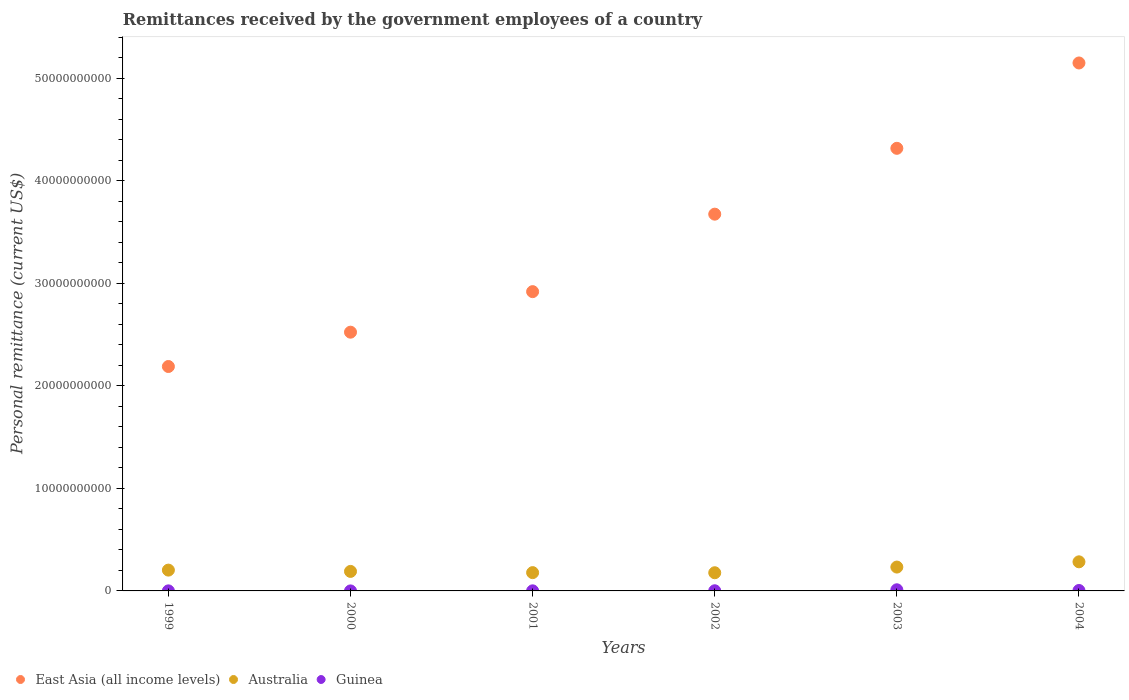What is the remittances received by the government employees in Guinea in 2002?
Offer a very short reply. 1.52e+07. Across all years, what is the maximum remittances received by the government employees in Australia?
Your answer should be compact. 2.84e+09. Across all years, what is the minimum remittances received by the government employees in East Asia (all income levels)?
Keep it short and to the point. 2.19e+1. In which year was the remittances received by the government employees in Australia minimum?
Make the answer very short. 2002. What is the total remittances received by the government employees in East Asia (all income levels) in the graph?
Offer a very short reply. 2.08e+11. What is the difference between the remittances received by the government employees in East Asia (all income levels) in 2000 and that in 2003?
Offer a terse response. -1.79e+1. What is the difference between the remittances received by the government employees in Australia in 2004 and the remittances received by the government employees in Guinea in 2003?
Make the answer very short. 2.73e+09. What is the average remittances received by the government employees in Guinea per year?
Ensure brevity in your answer.  3.06e+07. In the year 1999, what is the difference between the remittances received by the government employees in Australia and remittances received by the government employees in East Asia (all income levels)?
Your response must be concise. -1.99e+1. In how many years, is the remittances received by the government employees in Guinea greater than 34000000000 US$?
Keep it short and to the point. 0. What is the ratio of the remittances received by the government employees in East Asia (all income levels) in 2000 to that in 2002?
Offer a terse response. 0.69. Is the remittances received by the government employees in East Asia (all income levels) in 1999 less than that in 2002?
Your response must be concise. Yes. Is the difference between the remittances received by the government employees in Australia in 2001 and 2002 greater than the difference between the remittances received by the government employees in East Asia (all income levels) in 2001 and 2002?
Ensure brevity in your answer.  Yes. What is the difference between the highest and the second highest remittances received by the government employees in Guinea?
Your response must be concise. 6.94e+07. What is the difference between the highest and the lowest remittances received by the government employees in Guinea?
Your answer should be compact. 1.10e+08. In how many years, is the remittances received by the government employees in Guinea greater than the average remittances received by the government employees in Guinea taken over all years?
Ensure brevity in your answer.  2. Is it the case that in every year, the sum of the remittances received by the government employees in Australia and remittances received by the government employees in East Asia (all income levels)  is greater than the remittances received by the government employees in Guinea?
Ensure brevity in your answer.  Yes. Is the remittances received by the government employees in Australia strictly greater than the remittances received by the government employees in East Asia (all income levels) over the years?
Your answer should be compact. No. What is the difference between two consecutive major ticks on the Y-axis?
Give a very brief answer. 1.00e+1. Are the values on the major ticks of Y-axis written in scientific E-notation?
Your answer should be very brief. No. Does the graph contain grids?
Your answer should be very brief. No. Where does the legend appear in the graph?
Your answer should be compact. Bottom left. How many legend labels are there?
Offer a very short reply. 3. What is the title of the graph?
Offer a very short reply. Remittances received by the government employees of a country. What is the label or title of the X-axis?
Offer a terse response. Years. What is the label or title of the Y-axis?
Keep it short and to the point. Personal remittance (current US$). What is the Personal remittance (current US$) in East Asia (all income levels) in 1999?
Offer a terse response. 2.19e+1. What is the Personal remittance (current US$) in Australia in 1999?
Ensure brevity in your answer.  2.03e+09. What is the Personal remittance (current US$) of Guinea in 1999?
Give a very brief answer. 6.02e+06. What is the Personal remittance (current US$) of East Asia (all income levels) in 2000?
Your response must be concise. 2.52e+1. What is the Personal remittance (current US$) of Australia in 2000?
Keep it short and to the point. 1.90e+09. What is the Personal remittance (current US$) of Guinea in 2000?
Offer a terse response. 1.17e+06. What is the Personal remittance (current US$) of East Asia (all income levels) in 2001?
Provide a short and direct response. 2.92e+1. What is the Personal remittance (current US$) in Australia in 2001?
Provide a short and direct response. 1.78e+09. What is the Personal remittance (current US$) in Guinea in 2001?
Ensure brevity in your answer.  8.72e+06. What is the Personal remittance (current US$) of East Asia (all income levels) in 2002?
Keep it short and to the point. 3.67e+1. What is the Personal remittance (current US$) of Australia in 2002?
Give a very brief answer. 1.77e+09. What is the Personal remittance (current US$) of Guinea in 2002?
Provide a succinct answer. 1.52e+07. What is the Personal remittance (current US$) in East Asia (all income levels) in 2003?
Your answer should be compact. 4.32e+1. What is the Personal remittance (current US$) in Australia in 2003?
Make the answer very short. 2.33e+09. What is the Personal remittance (current US$) in Guinea in 2003?
Ensure brevity in your answer.  1.11e+08. What is the Personal remittance (current US$) of East Asia (all income levels) in 2004?
Ensure brevity in your answer.  5.15e+1. What is the Personal remittance (current US$) of Australia in 2004?
Keep it short and to the point. 2.84e+09. What is the Personal remittance (current US$) of Guinea in 2004?
Ensure brevity in your answer.  4.16e+07. Across all years, what is the maximum Personal remittance (current US$) in East Asia (all income levels)?
Ensure brevity in your answer.  5.15e+1. Across all years, what is the maximum Personal remittance (current US$) of Australia?
Provide a succinct answer. 2.84e+09. Across all years, what is the maximum Personal remittance (current US$) of Guinea?
Provide a succinct answer. 1.11e+08. Across all years, what is the minimum Personal remittance (current US$) in East Asia (all income levels)?
Provide a short and direct response. 2.19e+1. Across all years, what is the minimum Personal remittance (current US$) of Australia?
Your answer should be very brief. 1.77e+09. Across all years, what is the minimum Personal remittance (current US$) in Guinea?
Your response must be concise. 1.17e+06. What is the total Personal remittance (current US$) in East Asia (all income levels) in the graph?
Give a very brief answer. 2.08e+11. What is the total Personal remittance (current US$) in Australia in the graph?
Your response must be concise. 1.27e+1. What is the total Personal remittance (current US$) of Guinea in the graph?
Give a very brief answer. 1.84e+08. What is the difference between the Personal remittance (current US$) in East Asia (all income levels) in 1999 and that in 2000?
Provide a short and direct response. -3.35e+09. What is the difference between the Personal remittance (current US$) in Australia in 1999 and that in 2000?
Your answer should be compact. 1.26e+08. What is the difference between the Personal remittance (current US$) of Guinea in 1999 and that in 2000?
Give a very brief answer. 4.85e+06. What is the difference between the Personal remittance (current US$) in East Asia (all income levels) in 1999 and that in 2001?
Make the answer very short. -7.30e+09. What is the difference between the Personal remittance (current US$) of Australia in 1999 and that in 2001?
Provide a succinct answer. 2.46e+08. What is the difference between the Personal remittance (current US$) of Guinea in 1999 and that in 2001?
Provide a succinct answer. -2.70e+06. What is the difference between the Personal remittance (current US$) in East Asia (all income levels) in 1999 and that in 2002?
Your answer should be very brief. -1.49e+1. What is the difference between the Personal remittance (current US$) of Australia in 1999 and that in 2002?
Keep it short and to the point. 2.57e+08. What is the difference between the Personal remittance (current US$) in Guinea in 1999 and that in 2002?
Offer a terse response. -9.17e+06. What is the difference between the Personal remittance (current US$) of East Asia (all income levels) in 1999 and that in 2003?
Provide a short and direct response. -2.13e+1. What is the difference between the Personal remittance (current US$) in Australia in 1999 and that in 2003?
Give a very brief answer. -2.97e+08. What is the difference between the Personal remittance (current US$) of Guinea in 1999 and that in 2003?
Your response must be concise. -1.05e+08. What is the difference between the Personal remittance (current US$) in East Asia (all income levels) in 1999 and that in 2004?
Provide a short and direct response. -2.96e+1. What is the difference between the Personal remittance (current US$) of Australia in 1999 and that in 2004?
Provide a short and direct response. -8.08e+08. What is the difference between the Personal remittance (current US$) in Guinea in 1999 and that in 2004?
Ensure brevity in your answer.  -3.56e+07. What is the difference between the Personal remittance (current US$) of East Asia (all income levels) in 2000 and that in 2001?
Keep it short and to the point. -3.95e+09. What is the difference between the Personal remittance (current US$) of Australia in 2000 and that in 2001?
Offer a terse response. 1.20e+08. What is the difference between the Personal remittance (current US$) in Guinea in 2000 and that in 2001?
Ensure brevity in your answer.  -7.55e+06. What is the difference between the Personal remittance (current US$) in East Asia (all income levels) in 2000 and that in 2002?
Your response must be concise. -1.15e+1. What is the difference between the Personal remittance (current US$) in Australia in 2000 and that in 2002?
Your response must be concise. 1.31e+08. What is the difference between the Personal remittance (current US$) in Guinea in 2000 and that in 2002?
Give a very brief answer. -1.40e+07. What is the difference between the Personal remittance (current US$) of East Asia (all income levels) in 2000 and that in 2003?
Provide a short and direct response. -1.79e+1. What is the difference between the Personal remittance (current US$) of Australia in 2000 and that in 2003?
Provide a succinct answer. -4.23e+08. What is the difference between the Personal remittance (current US$) of Guinea in 2000 and that in 2003?
Give a very brief answer. -1.10e+08. What is the difference between the Personal remittance (current US$) of East Asia (all income levels) in 2000 and that in 2004?
Give a very brief answer. -2.63e+1. What is the difference between the Personal remittance (current US$) in Australia in 2000 and that in 2004?
Make the answer very short. -9.34e+08. What is the difference between the Personal remittance (current US$) in Guinea in 2000 and that in 2004?
Ensure brevity in your answer.  -4.05e+07. What is the difference between the Personal remittance (current US$) in East Asia (all income levels) in 2001 and that in 2002?
Keep it short and to the point. -7.56e+09. What is the difference between the Personal remittance (current US$) of Australia in 2001 and that in 2002?
Provide a short and direct response. 1.09e+07. What is the difference between the Personal remittance (current US$) in Guinea in 2001 and that in 2002?
Make the answer very short. -6.47e+06. What is the difference between the Personal remittance (current US$) in East Asia (all income levels) in 2001 and that in 2003?
Your answer should be compact. -1.40e+1. What is the difference between the Personal remittance (current US$) in Australia in 2001 and that in 2003?
Make the answer very short. -5.43e+08. What is the difference between the Personal remittance (current US$) of Guinea in 2001 and that in 2003?
Provide a short and direct response. -1.02e+08. What is the difference between the Personal remittance (current US$) in East Asia (all income levels) in 2001 and that in 2004?
Provide a short and direct response. -2.23e+1. What is the difference between the Personal remittance (current US$) in Australia in 2001 and that in 2004?
Your answer should be very brief. -1.05e+09. What is the difference between the Personal remittance (current US$) in Guinea in 2001 and that in 2004?
Give a very brief answer. -3.29e+07. What is the difference between the Personal remittance (current US$) of East Asia (all income levels) in 2002 and that in 2003?
Your answer should be very brief. -6.42e+09. What is the difference between the Personal remittance (current US$) in Australia in 2002 and that in 2003?
Offer a terse response. -5.54e+08. What is the difference between the Personal remittance (current US$) in Guinea in 2002 and that in 2003?
Your response must be concise. -9.59e+07. What is the difference between the Personal remittance (current US$) in East Asia (all income levels) in 2002 and that in 2004?
Keep it short and to the point. -1.47e+1. What is the difference between the Personal remittance (current US$) in Australia in 2002 and that in 2004?
Offer a very short reply. -1.06e+09. What is the difference between the Personal remittance (current US$) of Guinea in 2002 and that in 2004?
Give a very brief answer. -2.64e+07. What is the difference between the Personal remittance (current US$) of East Asia (all income levels) in 2003 and that in 2004?
Offer a terse response. -8.32e+09. What is the difference between the Personal remittance (current US$) of Australia in 2003 and that in 2004?
Your answer should be compact. -5.11e+08. What is the difference between the Personal remittance (current US$) in Guinea in 2003 and that in 2004?
Give a very brief answer. 6.94e+07. What is the difference between the Personal remittance (current US$) of East Asia (all income levels) in 1999 and the Personal remittance (current US$) of Australia in 2000?
Offer a very short reply. 2.00e+1. What is the difference between the Personal remittance (current US$) of East Asia (all income levels) in 1999 and the Personal remittance (current US$) of Guinea in 2000?
Your answer should be compact. 2.19e+1. What is the difference between the Personal remittance (current US$) of Australia in 1999 and the Personal remittance (current US$) of Guinea in 2000?
Your answer should be very brief. 2.03e+09. What is the difference between the Personal remittance (current US$) of East Asia (all income levels) in 1999 and the Personal remittance (current US$) of Australia in 2001?
Provide a short and direct response. 2.01e+1. What is the difference between the Personal remittance (current US$) of East Asia (all income levels) in 1999 and the Personal remittance (current US$) of Guinea in 2001?
Provide a short and direct response. 2.19e+1. What is the difference between the Personal remittance (current US$) of Australia in 1999 and the Personal remittance (current US$) of Guinea in 2001?
Offer a very short reply. 2.02e+09. What is the difference between the Personal remittance (current US$) of East Asia (all income levels) in 1999 and the Personal remittance (current US$) of Australia in 2002?
Make the answer very short. 2.01e+1. What is the difference between the Personal remittance (current US$) in East Asia (all income levels) in 1999 and the Personal remittance (current US$) in Guinea in 2002?
Give a very brief answer. 2.19e+1. What is the difference between the Personal remittance (current US$) of Australia in 1999 and the Personal remittance (current US$) of Guinea in 2002?
Provide a short and direct response. 2.01e+09. What is the difference between the Personal remittance (current US$) in East Asia (all income levels) in 1999 and the Personal remittance (current US$) in Australia in 2003?
Provide a succinct answer. 1.96e+1. What is the difference between the Personal remittance (current US$) in East Asia (all income levels) in 1999 and the Personal remittance (current US$) in Guinea in 2003?
Your answer should be very brief. 2.18e+1. What is the difference between the Personal remittance (current US$) of Australia in 1999 and the Personal remittance (current US$) of Guinea in 2003?
Offer a terse response. 1.92e+09. What is the difference between the Personal remittance (current US$) of East Asia (all income levels) in 1999 and the Personal remittance (current US$) of Australia in 2004?
Your answer should be compact. 1.90e+1. What is the difference between the Personal remittance (current US$) of East Asia (all income levels) in 1999 and the Personal remittance (current US$) of Guinea in 2004?
Your answer should be very brief. 2.18e+1. What is the difference between the Personal remittance (current US$) in Australia in 1999 and the Personal remittance (current US$) in Guinea in 2004?
Offer a terse response. 1.99e+09. What is the difference between the Personal remittance (current US$) of East Asia (all income levels) in 2000 and the Personal remittance (current US$) of Australia in 2001?
Ensure brevity in your answer.  2.34e+1. What is the difference between the Personal remittance (current US$) in East Asia (all income levels) in 2000 and the Personal remittance (current US$) in Guinea in 2001?
Keep it short and to the point. 2.52e+1. What is the difference between the Personal remittance (current US$) in Australia in 2000 and the Personal remittance (current US$) in Guinea in 2001?
Give a very brief answer. 1.89e+09. What is the difference between the Personal remittance (current US$) in East Asia (all income levels) in 2000 and the Personal remittance (current US$) in Australia in 2002?
Offer a very short reply. 2.35e+1. What is the difference between the Personal remittance (current US$) of East Asia (all income levels) in 2000 and the Personal remittance (current US$) of Guinea in 2002?
Offer a very short reply. 2.52e+1. What is the difference between the Personal remittance (current US$) of Australia in 2000 and the Personal remittance (current US$) of Guinea in 2002?
Provide a short and direct response. 1.89e+09. What is the difference between the Personal remittance (current US$) of East Asia (all income levels) in 2000 and the Personal remittance (current US$) of Australia in 2003?
Your answer should be compact. 2.29e+1. What is the difference between the Personal remittance (current US$) in East Asia (all income levels) in 2000 and the Personal remittance (current US$) in Guinea in 2003?
Make the answer very short. 2.51e+1. What is the difference between the Personal remittance (current US$) in Australia in 2000 and the Personal remittance (current US$) in Guinea in 2003?
Offer a very short reply. 1.79e+09. What is the difference between the Personal remittance (current US$) of East Asia (all income levels) in 2000 and the Personal remittance (current US$) of Australia in 2004?
Give a very brief answer. 2.24e+1. What is the difference between the Personal remittance (current US$) in East Asia (all income levels) in 2000 and the Personal remittance (current US$) in Guinea in 2004?
Provide a short and direct response. 2.52e+1. What is the difference between the Personal remittance (current US$) in Australia in 2000 and the Personal remittance (current US$) in Guinea in 2004?
Give a very brief answer. 1.86e+09. What is the difference between the Personal remittance (current US$) of East Asia (all income levels) in 2001 and the Personal remittance (current US$) of Australia in 2002?
Make the answer very short. 2.74e+1. What is the difference between the Personal remittance (current US$) in East Asia (all income levels) in 2001 and the Personal remittance (current US$) in Guinea in 2002?
Make the answer very short. 2.92e+1. What is the difference between the Personal remittance (current US$) of Australia in 2001 and the Personal remittance (current US$) of Guinea in 2002?
Provide a succinct answer. 1.77e+09. What is the difference between the Personal remittance (current US$) of East Asia (all income levels) in 2001 and the Personal remittance (current US$) of Australia in 2003?
Make the answer very short. 2.69e+1. What is the difference between the Personal remittance (current US$) in East Asia (all income levels) in 2001 and the Personal remittance (current US$) in Guinea in 2003?
Your response must be concise. 2.91e+1. What is the difference between the Personal remittance (current US$) in Australia in 2001 and the Personal remittance (current US$) in Guinea in 2003?
Offer a terse response. 1.67e+09. What is the difference between the Personal remittance (current US$) of East Asia (all income levels) in 2001 and the Personal remittance (current US$) of Australia in 2004?
Ensure brevity in your answer.  2.63e+1. What is the difference between the Personal remittance (current US$) of East Asia (all income levels) in 2001 and the Personal remittance (current US$) of Guinea in 2004?
Your answer should be very brief. 2.91e+1. What is the difference between the Personal remittance (current US$) in Australia in 2001 and the Personal remittance (current US$) in Guinea in 2004?
Provide a succinct answer. 1.74e+09. What is the difference between the Personal remittance (current US$) in East Asia (all income levels) in 2002 and the Personal remittance (current US$) in Australia in 2003?
Your answer should be very brief. 3.44e+1. What is the difference between the Personal remittance (current US$) of East Asia (all income levels) in 2002 and the Personal remittance (current US$) of Guinea in 2003?
Ensure brevity in your answer.  3.66e+1. What is the difference between the Personal remittance (current US$) in Australia in 2002 and the Personal remittance (current US$) in Guinea in 2003?
Offer a very short reply. 1.66e+09. What is the difference between the Personal remittance (current US$) in East Asia (all income levels) in 2002 and the Personal remittance (current US$) in Australia in 2004?
Provide a short and direct response. 3.39e+1. What is the difference between the Personal remittance (current US$) of East Asia (all income levels) in 2002 and the Personal remittance (current US$) of Guinea in 2004?
Offer a very short reply. 3.67e+1. What is the difference between the Personal remittance (current US$) in Australia in 2002 and the Personal remittance (current US$) in Guinea in 2004?
Provide a succinct answer. 1.73e+09. What is the difference between the Personal remittance (current US$) of East Asia (all income levels) in 2003 and the Personal remittance (current US$) of Australia in 2004?
Ensure brevity in your answer.  4.03e+1. What is the difference between the Personal remittance (current US$) of East Asia (all income levels) in 2003 and the Personal remittance (current US$) of Guinea in 2004?
Your response must be concise. 4.31e+1. What is the difference between the Personal remittance (current US$) of Australia in 2003 and the Personal remittance (current US$) of Guinea in 2004?
Your answer should be compact. 2.28e+09. What is the average Personal remittance (current US$) of East Asia (all income levels) per year?
Make the answer very short. 3.46e+1. What is the average Personal remittance (current US$) in Australia per year?
Give a very brief answer. 2.11e+09. What is the average Personal remittance (current US$) in Guinea per year?
Provide a short and direct response. 3.06e+07. In the year 1999, what is the difference between the Personal remittance (current US$) of East Asia (all income levels) and Personal remittance (current US$) of Australia?
Offer a very short reply. 1.99e+1. In the year 1999, what is the difference between the Personal remittance (current US$) of East Asia (all income levels) and Personal remittance (current US$) of Guinea?
Your answer should be compact. 2.19e+1. In the year 1999, what is the difference between the Personal remittance (current US$) of Australia and Personal remittance (current US$) of Guinea?
Keep it short and to the point. 2.02e+09. In the year 2000, what is the difference between the Personal remittance (current US$) in East Asia (all income levels) and Personal remittance (current US$) in Australia?
Ensure brevity in your answer.  2.33e+1. In the year 2000, what is the difference between the Personal remittance (current US$) in East Asia (all income levels) and Personal remittance (current US$) in Guinea?
Provide a succinct answer. 2.52e+1. In the year 2000, what is the difference between the Personal remittance (current US$) of Australia and Personal remittance (current US$) of Guinea?
Provide a succinct answer. 1.90e+09. In the year 2001, what is the difference between the Personal remittance (current US$) in East Asia (all income levels) and Personal remittance (current US$) in Australia?
Your answer should be compact. 2.74e+1. In the year 2001, what is the difference between the Personal remittance (current US$) of East Asia (all income levels) and Personal remittance (current US$) of Guinea?
Provide a short and direct response. 2.92e+1. In the year 2001, what is the difference between the Personal remittance (current US$) of Australia and Personal remittance (current US$) of Guinea?
Offer a terse response. 1.77e+09. In the year 2002, what is the difference between the Personal remittance (current US$) of East Asia (all income levels) and Personal remittance (current US$) of Australia?
Your answer should be very brief. 3.50e+1. In the year 2002, what is the difference between the Personal remittance (current US$) of East Asia (all income levels) and Personal remittance (current US$) of Guinea?
Keep it short and to the point. 3.67e+1. In the year 2002, what is the difference between the Personal remittance (current US$) of Australia and Personal remittance (current US$) of Guinea?
Offer a terse response. 1.76e+09. In the year 2003, what is the difference between the Personal remittance (current US$) in East Asia (all income levels) and Personal remittance (current US$) in Australia?
Your answer should be very brief. 4.08e+1. In the year 2003, what is the difference between the Personal remittance (current US$) of East Asia (all income levels) and Personal remittance (current US$) of Guinea?
Offer a terse response. 4.31e+1. In the year 2003, what is the difference between the Personal remittance (current US$) of Australia and Personal remittance (current US$) of Guinea?
Your answer should be very brief. 2.22e+09. In the year 2004, what is the difference between the Personal remittance (current US$) of East Asia (all income levels) and Personal remittance (current US$) of Australia?
Ensure brevity in your answer.  4.86e+1. In the year 2004, what is the difference between the Personal remittance (current US$) in East Asia (all income levels) and Personal remittance (current US$) in Guinea?
Your response must be concise. 5.14e+1. In the year 2004, what is the difference between the Personal remittance (current US$) in Australia and Personal remittance (current US$) in Guinea?
Ensure brevity in your answer.  2.80e+09. What is the ratio of the Personal remittance (current US$) in East Asia (all income levels) in 1999 to that in 2000?
Offer a very short reply. 0.87. What is the ratio of the Personal remittance (current US$) in Australia in 1999 to that in 2000?
Provide a short and direct response. 1.07. What is the ratio of the Personal remittance (current US$) of Guinea in 1999 to that in 2000?
Offer a terse response. 5.16. What is the ratio of the Personal remittance (current US$) in East Asia (all income levels) in 1999 to that in 2001?
Your answer should be compact. 0.75. What is the ratio of the Personal remittance (current US$) in Australia in 1999 to that in 2001?
Provide a succinct answer. 1.14. What is the ratio of the Personal remittance (current US$) in Guinea in 1999 to that in 2001?
Provide a succinct answer. 0.69. What is the ratio of the Personal remittance (current US$) in East Asia (all income levels) in 1999 to that in 2002?
Give a very brief answer. 0.6. What is the ratio of the Personal remittance (current US$) of Australia in 1999 to that in 2002?
Provide a short and direct response. 1.15. What is the ratio of the Personal remittance (current US$) in Guinea in 1999 to that in 2002?
Ensure brevity in your answer.  0.4. What is the ratio of the Personal remittance (current US$) in East Asia (all income levels) in 1999 to that in 2003?
Offer a very short reply. 0.51. What is the ratio of the Personal remittance (current US$) in Australia in 1999 to that in 2003?
Ensure brevity in your answer.  0.87. What is the ratio of the Personal remittance (current US$) in Guinea in 1999 to that in 2003?
Ensure brevity in your answer.  0.05. What is the ratio of the Personal remittance (current US$) of East Asia (all income levels) in 1999 to that in 2004?
Offer a terse response. 0.43. What is the ratio of the Personal remittance (current US$) of Australia in 1999 to that in 2004?
Your answer should be very brief. 0.72. What is the ratio of the Personal remittance (current US$) of Guinea in 1999 to that in 2004?
Offer a terse response. 0.14. What is the ratio of the Personal remittance (current US$) of East Asia (all income levels) in 2000 to that in 2001?
Your response must be concise. 0.86. What is the ratio of the Personal remittance (current US$) in Australia in 2000 to that in 2001?
Ensure brevity in your answer.  1.07. What is the ratio of the Personal remittance (current US$) in Guinea in 2000 to that in 2001?
Provide a short and direct response. 0.13. What is the ratio of the Personal remittance (current US$) in East Asia (all income levels) in 2000 to that in 2002?
Provide a short and direct response. 0.69. What is the ratio of the Personal remittance (current US$) of Australia in 2000 to that in 2002?
Your response must be concise. 1.07. What is the ratio of the Personal remittance (current US$) in Guinea in 2000 to that in 2002?
Offer a terse response. 0.08. What is the ratio of the Personal remittance (current US$) of East Asia (all income levels) in 2000 to that in 2003?
Keep it short and to the point. 0.58. What is the ratio of the Personal remittance (current US$) of Australia in 2000 to that in 2003?
Ensure brevity in your answer.  0.82. What is the ratio of the Personal remittance (current US$) of Guinea in 2000 to that in 2003?
Offer a terse response. 0.01. What is the ratio of the Personal remittance (current US$) in East Asia (all income levels) in 2000 to that in 2004?
Give a very brief answer. 0.49. What is the ratio of the Personal remittance (current US$) of Australia in 2000 to that in 2004?
Your answer should be very brief. 0.67. What is the ratio of the Personal remittance (current US$) in Guinea in 2000 to that in 2004?
Your response must be concise. 0.03. What is the ratio of the Personal remittance (current US$) in East Asia (all income levels) in 2001 to that in 2002?
Your answer should be very brief. 0.79. What is the ratio of the Personal remittance (current US$) in Australia in 2001 to that in 2002?
Provide a succinct answer. 1.01. What is the ratio of the Personal remittance (current US$) of Guinea in 2001 to that in 2002?
Your answer should be very brief. 0.57. What is the ratio of the Personal remittance (current US$) of East Asia (all income levels) in 2001 to that in 2003?
Ensure brevity in your answer.  0.68. What is the ratio of the Personal remittance (current US$) in Australia in 2001 to that in 2003?
Give a very brief answer. 0.77. What is the ratio of the Personal remittance (current US$) in Guinea in 2001 to that in 2003?
Ensure brevity in your answer.  0.08. What is the ratio of the Personal remittance (current US$) in East Asia (all income levels) in 2001 to that in 2004?
Make the answer very short. 0.57. What is the ratio of the Personal remittance (current US$) in Australia in 2001 to that in 2004?
Make the answer very short. 0.63. What is the ratio of the Personal remittance (current US$) of Guinea in 2001 to that in 2004?
Offer a terse response. 0.21. What is the ratio of the Personal remittance (current US$) in East Asia (all income levels) in 2002 to that in 2003?
Ensure brevity in your answer.  0.85. What is the ratio of the Personal remittance (current US$) of Australia in 2002 to that in 2003?
Your answer should be compact. 0.76. What is the ratio of the Personal remittance (current US$) of Guinea in 2002 to that in 2003?
Your answer should be compact. 0.14. What is the ratio of the Personal remittance (current US$) of East Asia (all income levels) in 2002 to that in 2004?
Your answer should be compact. 0.71. What is the ratio of the Personal remittance (current US$) in Australia in 2002 to that in 2004?
Your answer should be very brief. 0.62. What is the ratio of the Personal remittance (current US$) in Guinea in 2002 to that in 2004?
Your answer should be compact. 0.36. What is the ratio of the Personal remittance (current US$) in East Asia (all income levels) in 2003 to that in 2004?
Provide a succinct answer. 0.84. What is the ratio of the Personal remittance (current US$) of Australia in 2003 to that in 2004?
Keep it short and to the point. 0.82. What is the ratio of the Personal remittance (current US$) of Guinea in 2003 to that in 2004?
Offer a very short reply. 2.67. What is the difference between the highest and the second highest Personal remittance (current US$) of East Asia (all income levels)?
Ensure brevity in your answer.  8.32e+09. What is the difference between the highest and the second highest Personal remittance (current US$) in Australia?
Your answer should be very brief. 5.11e+08. What is the difference between the highest and the second highest Personal remittance (current US$) of Guinea?
Your answer should be very brief. 6.94e+07. What is the difference between the highest and the lowest Personal remittance (current US$) in East Asia (all income levels)?
Keep it short and to the point. 2.96e+1. What is the difference between the highest and the lowest Personal remittance (current US$) of Australia?
Provide a short and direct response. 1.06e+09. What is the difference between the highest and the lowest Personal remittance (current US$) in Guinea?
Give a very brief answer. 1.10e+08. 